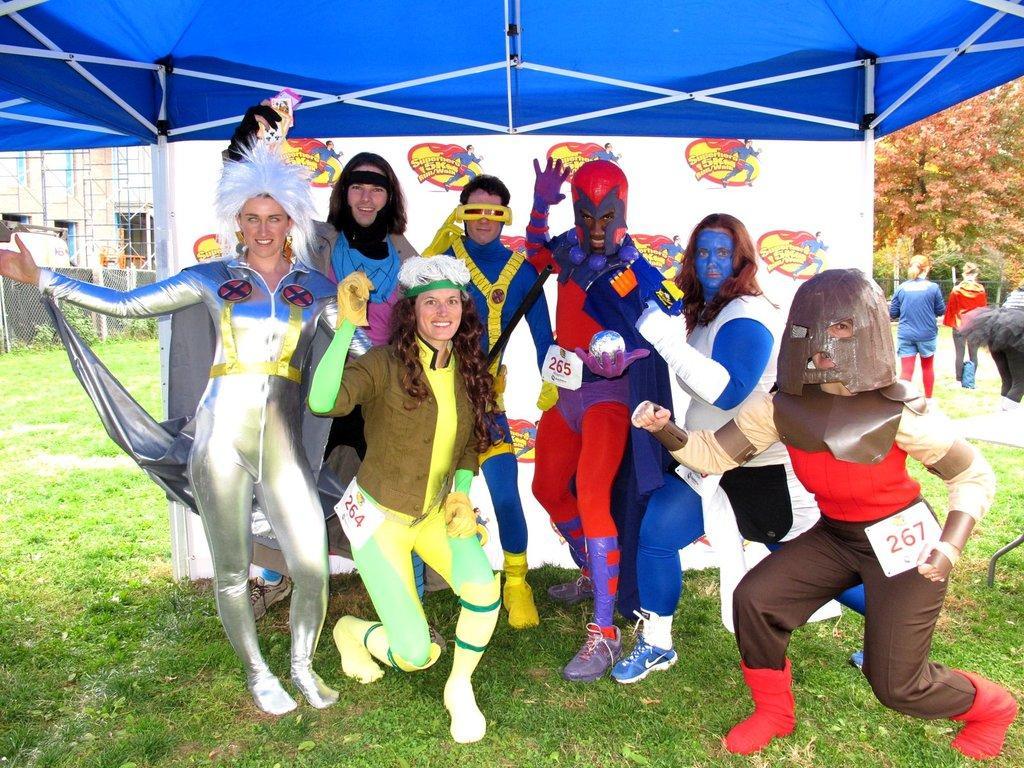Could you give a brief overview of what you see in this image? In this image, we can see people wearing costumes and in the background, there is a tent and we can see some logos on the board and there are trees, a building, a mesh and some rods. At the bottom, there is ground. 